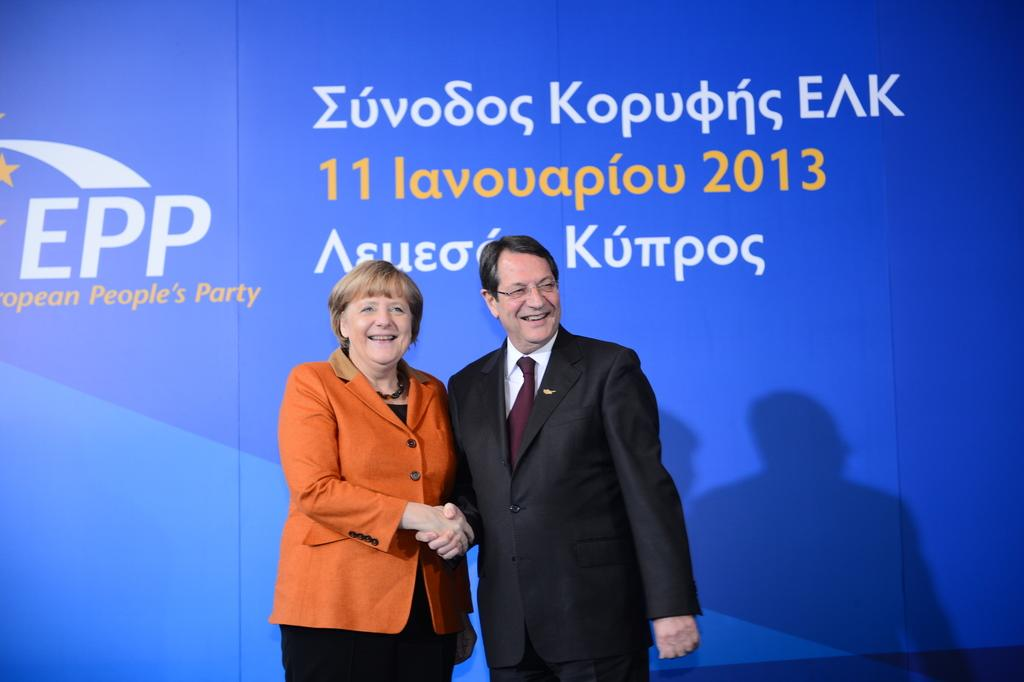What is the man in the image wearing? The man is wearing a suit. What is the woman in the image wearing? The woman is wearing an orange coat. What are the man and woman doing in the image? The man and woman are shaking hands and smiling. What color is the banner in the image? The banner in the image is blue. What type of berry can be seen on the man's suit in the image? There are no berries present on the man's suit in the image. 